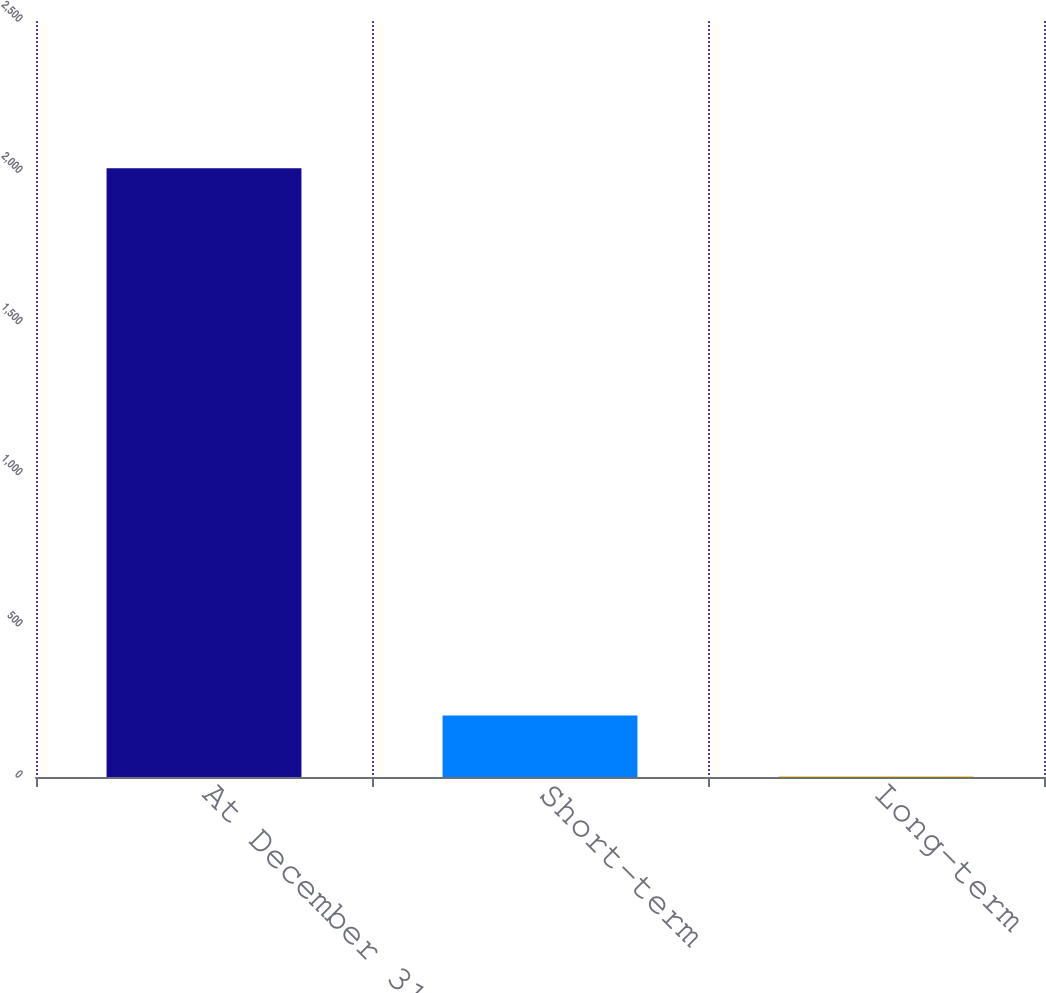Convert chart to OTSL. <chart><loc_0><loc_0><loc_500><loc_500><bar_chart><fcel>At December 31<fcel>Short-term<fcel>Long-term<nl><fcel>2013<fcel>203.6<fcel>2.56<nl></chart> 